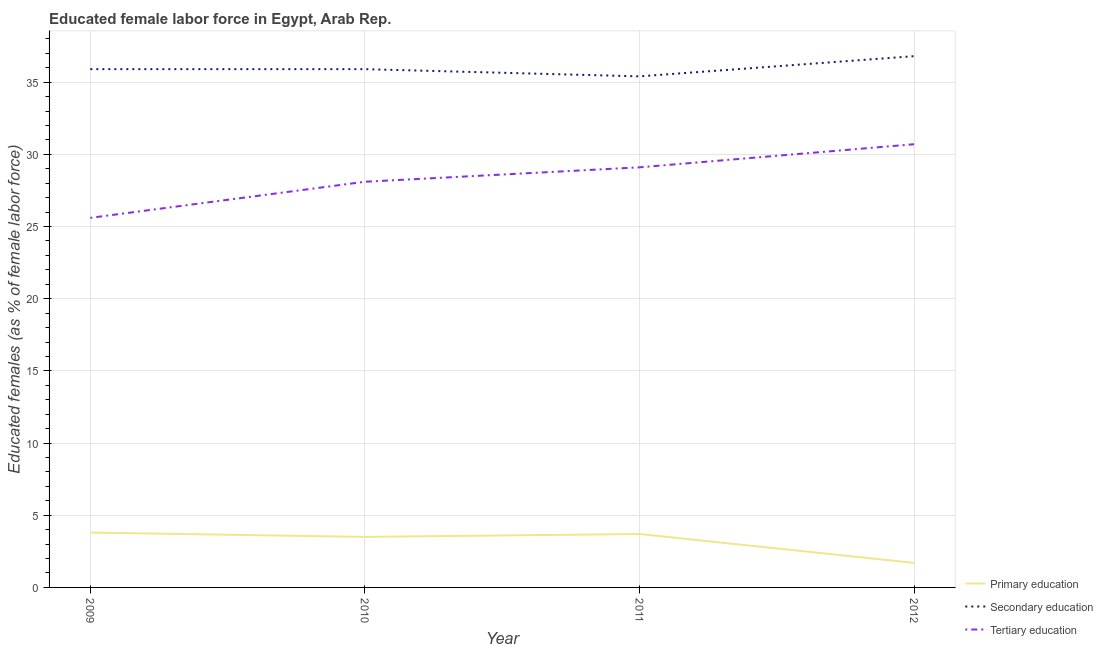What is the percentage of female labor force who received secondary education in 2012?
Offer a very short reply. 36.8. Across all years, what is the maximum percentage of female labor force who received primary education?
Make the answer very short. 3.8. Across all years, what is the minimum percentage of female labor force who received tertiary education?
Offer a terse response. 25.6. In which year was the percentage of female labor force who received secondary education minimum?
Your answer should be compact. 2011. What is the total percentage of female labor force who received secondary education in the graph?
Ensure brevity in your answer.  144. What is the difference between the percentage of female labor force who received secondary education in 2010 and that in 2011?
Your response must be concise. 0.5. What is the difference between the percentage of female labor force who received primary education in 2010 and the percentage of female labor force who received secondary education in 2009?
Offer a very short reply. -32.4. What is the average percentage of female labor force who received primary education per year?
Your answer should be compact. 3.18. In the year 2009, what is the difference between the percentage of female labor force who received primary education and percentage of female labor force who received secondary education?
Make the answer very short. -32.1. What is the ratio of the percentage of female labor force who received primary education in 2009 to that in 2012?
Your response must be concise. 2.24. Is the percentage of female labor force who received primary education in 2009 less than that in 2011?
Give a very brief answer. No. Is the difference between the percentage of female labor force who received tertiary education in 2009 and 2010 greater than the difference between the percentage of female labor force who received secondary education in 2009 and 2010?
Ensure brevity in your answer.  No. What is the difference between the highest and the second highest percentage of female labor force who received primary education?
Provide a succinct answer. 0.1. What is the difference between the highest and the lowest percentage of female labor force who received tertiary education?
Your answer should be very brief. 5.1. In how many years, is the percentage of female labor force who received tertiary education greater than the average percentage of female labor force who received tertiary education taken over all years?
Offer a very short reply. 2. Is the sum of the percentage of female labor force who received primary education in 2009 and 2010 greater than the maximum percentage of female labor force who received secondary education across all years?
Your answer should be compact. No. Is it the case that in every year, the sum of the percentage of female labor force who received primary education and percentage of female labor force who received secondary education is greater than the percentage of female labor force who received tertiary education?
Your response must be concise. Yes. Does the percentage of female labor force who received tertiary education monotonically increase over the years?
Offer a very short reply. Yes. How many lines are there?
Ensure brevity in your answer.  3. Are the values on the major ticks of Y-axis written in scientific E-notation?
Your answer should be very brief. No. Does the graph contain any zero values?
Your answer should be compact. No. Does the graph contain grids?
Your answer should be compact. Yes. Where does the legend appear in the graph?
Ensure brevity in your answer.  Bottom right. How many legend labels are there?
Ensure brevity in your answer.  3. What is the title of the graph?
Provide a short and direct response. Educated female labor force in Egypt, Arab Rep. Does "Domestic economy" appear as one of the legend labels in the graph?
Provide a succinct answer. No. What is the label or title of the X-axis?
Ensure brevity in your answer.  Year. What is the label or title of the Y-axis?
Your answer should be very brief. Educated females (as % of female labor force). What is the Educated females (as % of female labor force) in Primary education in 2009?
Make the answer very short. 3.8. What is the Educated females (as % of female labor force) of Secondary education in 2009?
Ensure brevity in your answer.  35.9. What is the Educated females (as % of female labor force) in Tertiary education in 2009?
Give a very brief answer. 25.6. What is the Educated females (as % of female labor force) of Secondary education in 2010?
Your answer should be compact. 35.9. What is the Educated females (as % of female labor force) of Tertiary education in 2010?
Ensure brevity in your answer.  28.1. What is the Educated females (as % of female labor force) of Primary education in 2011?
Offer a very short reply. 3.7. What is the Educated females (as % of female labor force) of Secondary education in 2011?
Your answer should be compact. 35.4. What is the Educated females (as % of female labor force) of Tertiary education in 2011?
Your answer should be compact. 29.1. What is the Educated females (as % of female labor force) in Primary education in 2012?
Ensure brevity in your answer.  1.7. What is the Educated females (as % of female labor force) in Secondary education in 2012?
Your response must be concise. 36.8. What is the Educated females (as % of female labor force) in Tertiary education in 2012?
Keep it short and to the point. 30.7. Across all years, what is the maximum Educated females (as % of female labor force) of Primary education?
Ensure brevity in your answer.  3.8. Across all years, what is the maximum Educated females (as % of female labor force) in Secondary education?
Provide a succinct answer. 36.8. Across all years, what is the maximum Educated females (as % of female labor force) of Tertiary education?
Your answer should be compact. 30.7. Across all years, what is the minimum Educated females (as % of female labor force) of Primary education?
Keep it short and to the point. 1.7. Across all years, what is the minimum Educated females (as % of female labor force) of Secondary education?
Provide a succinct answer. 35.4. Across all years, what is the minimum Educated females (as % of female labor force) of Tertiary education?
Make the answer very short. 25.6. What is the total Educated females (as % of female labor force) of Primary education in the graph?
Make the answer very short. 12.7. What is the total Educated females (as % of female labor force) of Secondary education in the graph?
Make the answer very short. 144. What is the total Educated females (as % of female labor force) of Tertiary education in the graph?
Provide a succinct answer. 113.5. What is the difference between the Educated females (as % of female labor force) in Secondary education in 2009 and that in 2010?
Offer a terse response. 0. What is the difference between the Educated females (as % of female labor force) in Tertiary education in 2009 and that in 2010?
Your response must be concise. -2.5. What is the difference between the Educated females (as % of female labor force) in Secondary education in 2009 and that in 2011?
Provide a short and direct response. 0.5. What is the difference between the Educated females (as % of female labor force) of Tertiary education in 2009 and that in 2011?
Provide a short and direct response. -3.5. What is the difference between the Educated females (as % of female labor force) in Tertiary education in 2009 and that in 2012?
Give a very brief answer. -5.1. What is the difference between the Educated females (as % of female labor force) in Secondary education in 2010 and that in 2011?
Make the answer very short. 0.5. What is the difference between the Educated females (as % of female labor force) of Tertiary education in 2010 and that in 2011?
Offer a terse response. -1. What is the difference between the Educated females (as % of female labor force) of Secondary education in 2010 and that in 2012?
Your answer should be compact. -0.9. What is the difference between the Educated females (as % of female labor force) of Secondary education in 2011 and that in 2012?
Your answer should be very brief. -1.4. What is the difference between the Educated females (as % of female labor force) in Primary education in 2009 and the Educated females (as % of female labor force) in Secondary education in 2010?
Your response must be concise. -32.1. What is the difference between the Educated females (as % of female labor force) of Primary education in 2009 and the Educated females (as % of female labor force) of Tertiary education in 2010?
Give a very brief answer. -24.3. What is the difference between the Educated females (as % of female labor force) in Primary education in 2009 and the Educated females (as % of female labor force) in Secondary education in 2011?
Provide a succinct answer. -31.6. What is the difference between the Educated females (as % of female labor force) in Primary education in 2009 and the Educated females (as % of female labor force) in Tertiary education in 2011?
Ensure brevity in your answer.  -25.3. What is the difference between the Educated females (as % of female labor force) of Secondary education in 2009 and the Educated females (as % of female labor force) of Tertiary education in 2011?
Your answer should be very brief. 6.8. What is the difference between the Educated females (as % of female labor force) in Primary education in 2009 and the Educated females (as % of female labor force) in Secondary education in 2012?
Your response must be concise. -33. What is the difference between the Educated females (as % of female labor force) in Primary education in 2009 and the Educated females (as % of female labor force) in Tertiary education in 2012?
Make the answer very short. -26.9. What is the difference between the Educated females (as % of female labor force) of Secondary education in 2009 and the Educated females (as % of female labor force) of Tertiary education in 2012?
Provide a short and direct response. 5.2. What is the difference between the Educated females (as % of female labor force) of Primary education in 2010 and the Educated females (as % of female labor force) of Secondary education in 2011?
Offer a terse response. -31.9. What is the difference between the Educated females (as % of female labor force) in Primary education in 2010 and the Educated females (as % of female labor force) in Tertiary education in 2011?
Your answer should be very brief. -25.6. What is the difference between the Educated females (as % of female labor force) of Primary education in 2010 and the Educated females (as % of female labor force) of Secondary education in 2012?
Your answer should be compact. -33.3. What is the difference between the Educated females (as % of female labor force) in Primary education in 2010 and the Educated females (as % of female labor force) in Tertiary education in 2012?
Offer a terse response. -27.2. What is the difference between the Educated females (as % of female labor force) in Primary education in 2011 and the Educated females (as % of female labor force) in Secondary education in 2012?
Keep it short and to the point. -33.1. What is the difference between the Educated females (as % of female labor force) of Secondary education in 2011 and the Educated females (as % of female labor force) of Tertiary education in 2012?
Your response must be concise. 4.7. What is the average Educated females (as % of female labor force) in Primary education per year?
Provide a short and direct response. 3.17. What is the average Educated females (as % of female labor force) in Secondary education per year?
Offer a terse response. 36. What is the average Educated females (as % of female labor force) in Tertiary education per year?
Ensure brevity in your answer.  28.38. In the year 2009, what is the difference between the Educated females (as % of female labor force) in Primary education and Educated females (as % of female labor force) in Secondary education?
Offer a very short reply. -32.1. In the year 2009, what is the difference between the Educated females (as % of female labor force) of Primary education and Educated females (as % of female labor force) of Tertiary education?
Ensure brevity in your answer.  -21.8. In the year 2010, what is the difference between the Educated females (as % of female labor force) of Primary education and Educated females (as % of female labor force) of Secondary education?
Your answer should be compact. -32.4. In the year 2010, what is the difference between the Educated females (as % of female labor force) of Primary education and Educated females (as % of female labor force) of Tertiary education?
Give a very brief answer. -24.6. In the year 2010, what is the difference between the Educated females (as % of female labor force) of Secondary education and Educated females (as % of female labor force) of Tertiary education?
Offer a terse response. 7.8. In the year 2011, what is the difference between the Educated females (as % of female labor force) of Primary education and Educated females (as % of female labor force) of Secondary education?
Your answer should be compact. -31.7. In the year 2011, what is the difference between the Educated females (as % of female labor force) in Primary education and Educated females (as % of female labor force) in Tertiary education?
Make the answer very short. -25.4. In the year 2012, what is the difference between the Educated females (as % of female labor force) of Primary education and Educated females (as % of female labor force) of Secondary education?
Provide a succinct answer. -35.1. In the year 2012, what is the difference between the Educated females (as % of female labor force) in Secondary education and Educated females (as % of female labor force) in Tertiary education?
Your answer should be very brief. 6.1. What is the ratio of the Educated females (as % of female labor force) in Primary education in 2009 to that in 2010?
Ensure brevity in your answer.  1.09. What is the ratio of the Educated females (as % of female labor force) of Tertiary education in 2009 to that in 2010?
Make the answer very short. 0.91. What is the ratio of the Educated females (as % of female labor force) in Primary education in 2009 to that in 2011?
Offer a very short reply. 1.03. What is the ratio of the Educated females (as % of female labor force) in Secondary education in 2009 to that in 2011?
Offer a very short reply. 1.01. What is the ratio of the Educated females (as % of female labor force) in Tertiary education in 2009 to that in 2011?
Keep it short and to the point. 0.88. What is the ratio of the Educated females (as % of female labor force) in Primary education in 2009 to that in 2012?
Keep it short and to the point. 2.24. What is the ratio of the Educated females (as % of female labor force) of Secondary education in 2009 to that in 2012?
Your response must be concise. 0.98. What is the ratio of the Educated females (as % of female labor force) in Tertiary education in 2009 to that in 2012?
Offer a terse response. 0.83. What is the ratio of the Educated females (as % of female labor force) of Primary education in 2010 to that in 2011?
Your response must be concise. 0.95. What is the ratio of the Educated females (as % of female labor force) in Secondary education in 2010 to that in 2011?
Give a very brief answer. 1.01. What is the ratio of the Educated females (as % of female labor force) in Tertiary education in 2010 to that in 2011?
Your response must be concise. 0.97. What is the ratio of the Educated females (as % of female labor force) in Primary education in 2010 to that in 2012?
Give a very brief answer. 2.06. What is the ratio of the Educated females (as % of female labor force) of Secondary education in 2010 to that in 2012?
Make the answer very short. 0.98. What is the ratio of the Educated females (as % of female labor force) in Tertiary education in 2010 to that in 2012?
Keep it short and to the point. 0.92. What is the ratio of the Educated females (as % of female labor force) in Primary education in 2011 to that in 2012?
Provide a succinct answer. 2.18. What is the ratio of the Educated females (as % of female labor force) in Secondary education in 2011 to that in 2012?
Your response must be concise. 0.96. What is the ratio of the Educated females (as % of female labor force) in Tertiary education in 2011 to that in 2012?
Ensure brevity in your answer.  0.95. What is the difference between the highest and the second highest Educated females (as % of female labor force) of Primary education?
Your response must be concise. 0.1. What is the difference between the highest and the lowest Educated females (as % of female labor force) in Primary education?
Ensure brevity in your answer.  2.1. What is the difference between the highest and the lowest Educated females (as % of female labor force) in Secondary education?
Give a very brief answer. 1.4. What is the difference between the highest and the lowest Educated females (as % of female labor force) of Tertiary education?
Offer a very short reply. 5.1. 